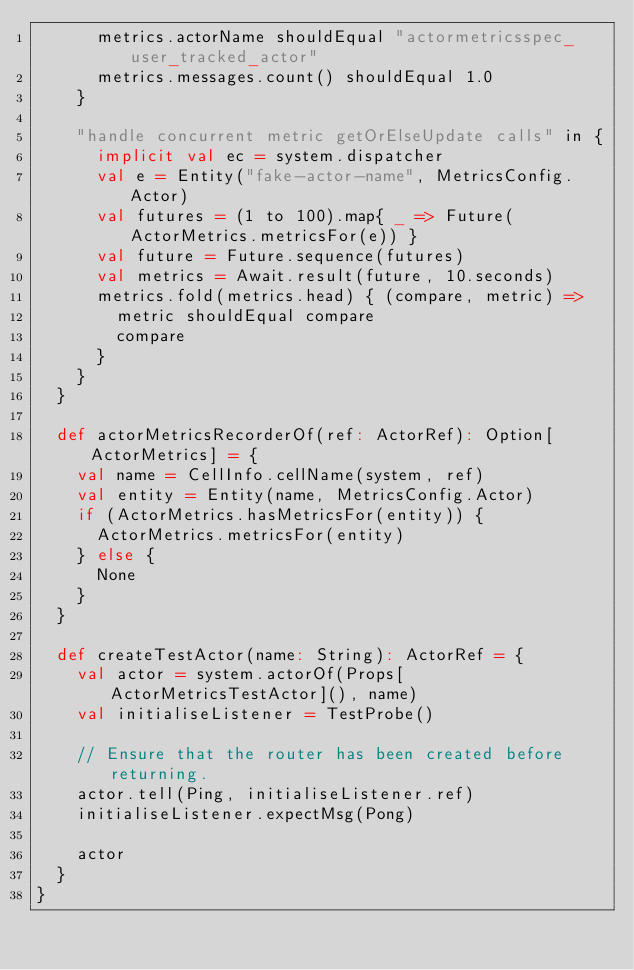Convert code to text. <code><loc_0><loc_0><loc_500><loc_500><_Scala_>      metrics.actorName shouldEqual "actormetricsspec_user_tracked_actor"
      metrics.messages.count() shouldEqual 1.0
    }

    "handle concurrent metric getOrElseUpdate calls" in {
      implicit val ec = system.dispatcher
      val e = Entity("fake-actor-name", MetricsConfig.Actor)
      val futures = (1 to 100).map{ _ => Future(ActorMetrics.metricsFor(e)) }
      val future = Future.sequence(futures)
      val metrics = Await.result(future, 10.seconds)
      metrics.fold(metrics.head) { (compare, metric) =>
        metric shouldEqual compare
        compare
      }
    }
  }

  def actorMetricsRecorderOf(ref: ActorRef): Option[ActorMetrics] = {
    val name = CellInfo.cellName(system, ref)
    val entity = Entity(name, MetricsConfig.Actor)
    if (ActorMetrics.hasMetricsFor(entity)) {
      ActorMetrics.metricsFor(entity)
    } else {
      None
    }
  }

  def createTestActor(name: String): ActorRef = {
    val actor = system.actorOf(Props[ActorMetricsTestActor](), name)
    val initialiseListener = TestProbe()

    // Ensure that the router has been created before returning.
    actor.tell(Ping, initialiseListener.ref)
    initialiseListener.expectMsg(Pong)

    actor
  }
}
</code> 